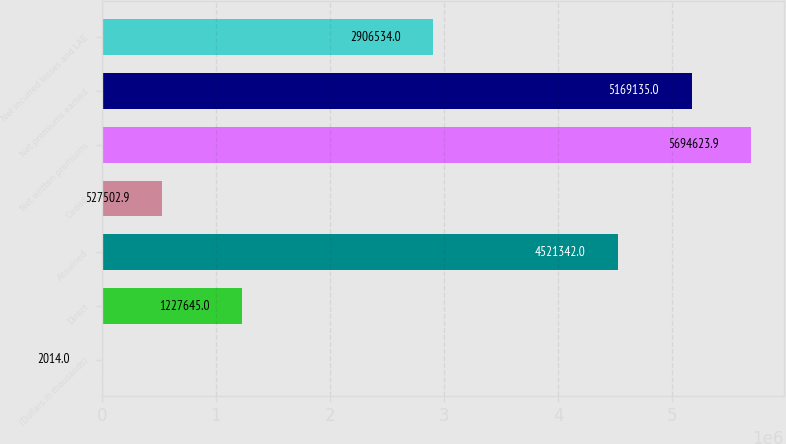<chart> <loc_0><loc_0><loc_500><loc_500><bar_chart><fcel>(Dollars in thousands)<fcel>Direct<fcel>Assumed<fcel>Ceded<fcel>Net written premiums<fcel>Net premiums earned<fcel>Net incurred losses and LAE<nl><fcel>2014<fcel>1.22764e+06<fcel>4.52134e+06<fcel>527503<fcel>5.69462e+06<fcel>5.16914e+06<fcel>2.90653e+06<nl></chart> 